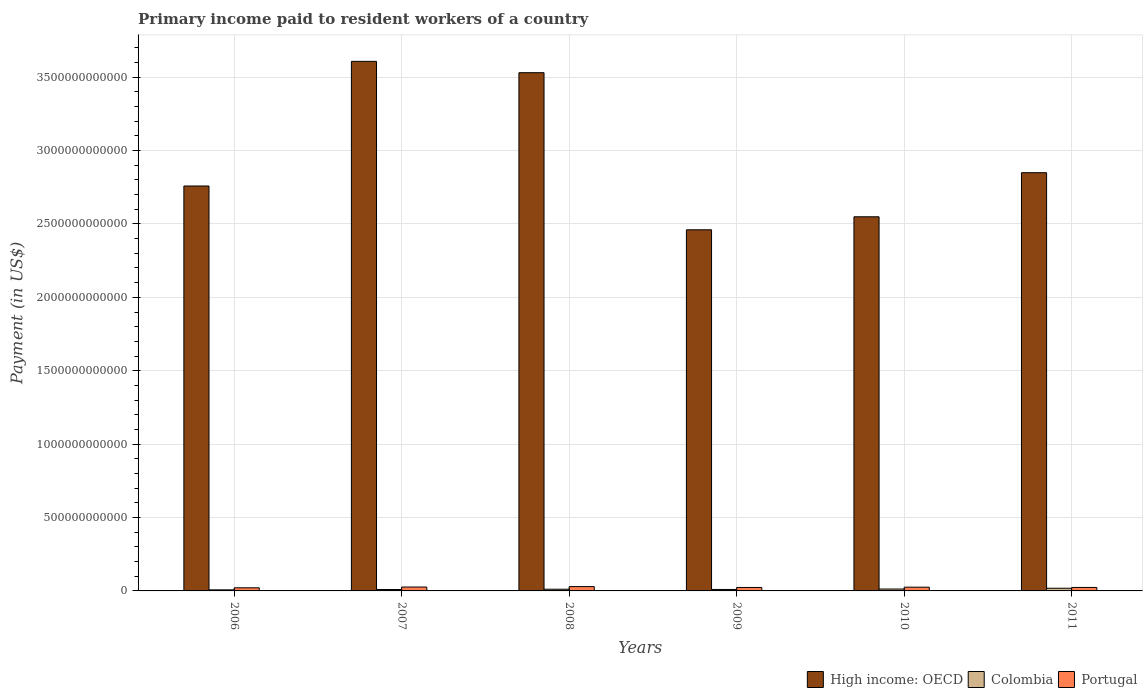How many bars are there on the 1st tick from the right?
Ensure brevity in your answer.  3. What is the amount paid to workers in Portugal in 2007?
Offer a terse response. 2.65e+1. Across all years, what is the maximum amount paid to workers in Portugal?
Your answer should be compact. 2.94e+1. Across all years, what is the minimum amount paid to workers in Colombia?
Your response must be concise. 7.27e+09. What is the total amount paid to workers in Portugal in the graph?
Your response must be concise. 1.50e+11. What is the difference between the amount paid to workers in Portugal in 2006 and that in 2009?
Your answer should be very brief. -2.39e+09. What is the difference between the amount paid to workers in Colombia in 2010 and the amount paid to workers in Portugal in 2009?
Your response must be concise. -1.07e+1. What is the average amount paid to workers in Colombia per year?
Provide a succinct answer. 1.16e+1. In the year 2007, what is the difference between the amount paid to workers in Colombia and amount paid to workers in Portugal?
Make the answer very short. -1.68e+1. What is the ratio of the amount paid to workers in Colombia in 2007 to that in 2011?
Offer a terse response. 0.53. Is the difference between the amount paid to workers in Colombia in 2007 and 2010 greater than the difference between the amount paid to workers in Portugal in 2007 and 2010?
Your response must be concise. No. What is the difference between the highest and the second highest amount paid to workers in Portugal?
Your answer should be compact. 2.91e+09. What is the difference between the highest and the lowest amount paid to workers in Colombia?
Give a very brief answer. 1.10e+1. In how many years, is the amount paid to workers in Colombia greater than the average amount paid to workers in Colombia taken over all years?
Offer a very short reply. 2. Is the sum of the amount paid to workers in Colombia in 2006 and 2009 greater than the maximum amount paid to workers in High income: OECD across all years?
Your response must be concise. No. What does the 2nd bar from the left in 2006 represents?
Keep it short and to the point. Colombia. What is the difference between two consecutive major ticks on the Y-axis?
Give a very brief answer. 5.00e+11. Does the graph contain grids?
Provide a succinct answer. Yes. How many legend labels are there?
Your answer should be compact. 3. What is the title of the graph?
Keep it short and to the point. Primary income paid to resident workers of a country. Does "Costa Rica" appear as one of the legend labels in the graph?
Your answer should be compact. No. What is the label or title of the Y-axis?
Provide a succinct answer. Payment (in US$). What is the Payment (in US$) of High income: OECD in 2006?
Your answer should be compact. 2.76e+12. What is the Payment (in US$) in Colombia in 2006?
Your answer should be compact. 7.27e+09. What is the Payment (in US$) in Portugal in 2006?
Keep it short and to the point. 2.12e+1. What is the Payment (in US$) in High income: OECD in 2007?
Your response must be concise. 3.61e+12. What is the Payment (in US$) of Colombia in 2007?
Give a very brief answer. 9.68e+09. What is the Payment (in US$) in Portugal in 2007?
Offer a very short reply. 2.65e+1. What is the Payment (in US$) of High income: OECD in 2008?
Offer a terse response. 3.53e+12. What is the Payment (in US$) of Colombia in 2008?
Offer a very short reply. 1.15e+1. What is the Payment (in US$) of Portugal in 2008?
Make the answer very short. 2.94e+1. What is the Payment (in US$) in High income: OECD in 2009?
Provide a succinct answer. 2.46e+12. What is the Payment (in US$) of Colombia in 2009?
Your response must be concise. 9.96e+09. What is the Payment (in US$) of Portugal in 2009?
Keep it short and to the point. 2.36e+1. What is the Payment (in US$) of High income: OECD in 2010?
Give a very brief answer. 2.55e+12. What is the Payment (in US$) in Colombia in 2010?
Your answer should be compact. 1.29e+1. What is the Payment (in US$) in Portugal in 2010?
Your answer should be very brief. 2.55e+1. What is the Payment (in US$) of High income: OECD in 2011?
Provide a short and direct response. 2.85e+12. What is the Payment (in US$) of Colombia in 2011?
Give a very brief answer. 1.83e+1. What is the Payment (in US$) in Portugal in 2011?
Your answer should be very brief. 2.36e+1. Across all years, what is the maximum Payment (in US$) of High income: OECD?
Offer a very short reply. 3.61e+12. Across all years, what is the maximum Payment (in US$) in Colombia?
Offer a very short reply. 1.83e+1. Across all years, what is the maximum Payment (in US$) of Portugal?
Offer a terse response. 2.94e+1. Across all years, what is the minimum Payment (in US$) in High income: OECD?
Your answer should be compact. 2.46e+12. Across all years, what is the minimum Payment (in US$) in Colombia?
Give a very brief answer. 7.27e+09. Across all years, what is the minimum Payment (in US$) of Portugal?
Make the answer very short. 2.12e+1. What is the total Payment (in US$) of High income: OECD in the graph?
Provide a succinct answer. 1.78e+13. What is the total Payment (in US$) of Colombia in the graph?
Keep it short and to the point. 6.96e+1. What is the total Payment (in US$) in Portugal in the graph?
Ensure brevity in your answer.  1.50e+11. What is the difference between the Payment (in US$) in High income: OECD in 2006 and that in 2007?
Ensure brevity in your answer.  -8.49e+11. What is the difference between the Payment (in US$) of Colombia in 2006 and that in 2007?
Your response must be concise. -2.42e+09. What is the difference between the Payment (in US$) of Portugal in 2006 and that in 2007?
Offer a terse response. -5.28e+09. What is the difference between the Payment (in US$) in High income: OECD in 2006 and that in 2008?
Give a very brief answer. -7.72e+11. What is the difference between the Payment (in US$) of Colombia in 2006 and that in 2008?
Give a very brief answer. -4.25e+09. What is the difference between the Payment (in US$) of Portugal in 2006 and that in 2008?
Ensure brevity in your answer.  -8.19e+09. What is the difference between the Payment (in US$) of High income: OECD in 2006 and that in 2009?
Make the answer very short. 2.98e+11. What is the difference between the Payment (in US$) of Colombia in 2006 and that in 2009?
Provide a short and direct response. -2.70e+09. What is the difference between the Payment (in US$) in Portugal in 2006 and that in 2009?
Provide a succinct answer. -2.39e+09. What is the difference between the Payment (in US$) of High income: OECD in 2006 and that in 2010?
Offer a very short reply. 2.10e+11. What is the difference between the Payment (in US$) in Colombia in 2006 and that in 2010?
Keep it short and to the point. -5.62e+09. What is the difference between the Payment (in US$) in Portugal in 2006 and that in 2010?
Keep it short and to the point. -4.24e+09. What is the difference between the Payment (in US$) of High income: OECD in 2006 and that in 2011?
Provide a succinct answer. -9.06e+1. What is the difference between the Payment (in US$) of Colombia in 2006 and that in 2011?
Provide a succinct answer. -1.10e+1. What is the difference between the Payment (in US$) in Portugal in 2006 and that in 2011?
Give a very brief answer. -2.42e+09. What is the difference between the Payment (in US$) in High income: OECD in 2007 and that in 2008?
Your answer should be compact. 7.73e+1. What is the difference between the Payment (in US$) in Colombia in 2007 and that in 2008?
Give a very brief answer. -1.83e+09. What is the difference between the Payment (in US$) in Portugal in 2007 and that in 2008?
Make the answer very short. -2.91e+09. What is the difference between the Payment (in US$) of High income: OECD in 2007 and that in 2009?
Give a very brief answer. 1.15e+12. What is the difference between the Payment (in US$) in Colombia in 2007 and that in 2009?
Offer a very short reply. -2.78e+08. What is the difference between the Payment (in US$) in Portugal in 2007 and that in 2009?
Provide a succinct answer. 2.89e+09. What is the difference between the Payment (in US$) of High income: OECD in 2007 and that in 2010?
Provide a short and direct response. 1.06e+12. What is the difference between the Payment (in US$) in Colombia in 2007 and that in 2010?
Offer a very short reply. -3.21e+09. What is the difference between the Payment (in US$) in Portugal in 2007 and that in 2010?
Make the answer very short. 1.03e+09. What is the difference between the Payment (in US$) in High income: OECD in 2007 and that in 2011?
Your answer should be very brief. 7.58e+11. What is the difference between the Payment (in US$) in Colombia in 2007 and that in 2011?
Keep it short and to the point. -8.58e+09. What is the difference between the Payment (in US$) in Portugal in 2007 and that in 2011?
Give a very brief answer. 2.85e+09. What is the difference between the Payment (in US$) of High income: OECD in 2008 and that in 2009?
Your response must be concise. 1.07e+12. What is the difference between the Payment (in US$) in Colombia in 2008 and that in 2009?
Keep it short and to the point. 1.55e+09. What is the difference between the Payment (in US$) of Portugal in 2008 and that in 2009?
Provide a succinct answer. 5.80e+09. What is the difference between the Payment (in US$) in High income: OECD in 2008 and that in 2010?
Give a very brief answer. 9.82e+11. What is the difference between the Payment (in US$) in Colombia in 2008 and that in 2010?
Offer a very short reply. -1.38e+09. What is the difference between the Payment (in US$) in Portugal in 2008 and that in 2010?
Ensure brevity in your answer.  3.95e+09. What is the difference between the Payment (in US$) of High income: OECD in 2008 and that in 2011?
Offer a very short reply. 6.81e+11. What is the difference between the Payment (in US$) in Colombia in 2008 and that in 2011?
Keep it short and to the point. -6.75e+09. What is the difference between the Payment (in US$) in Portugal in 2008 and that in 2011?
Give a very brief answer. 5.77e+09. What is the difference between the Payment (in US$) in High income: OECD in 2009 and that in 2010?
Ensure brevity in your answer.  -8.86e+1. What is the difference between the Payment (in US$) of Colombia in 2009 and that in 2010?
Your response must be concise. -2.93e+09. What is the difference between the Payment (in US$) in Portugal in 2009 and that in 2010?
Provide a succinct answer. -1.86e+09. What is the difference between the Payment (in US$) of High income: OECD in 2009 and that in 2011?
Offer a terse response. -3.89e+11. What is the difference between the Payment (in US$) in Colombia in 2009 and that in 2011?
Offer a very short reply. -8.30e+09. What is the difference between the Payment (in US$) in Portugal in 2009 and that in 2011?
Your response must be concise. -3.41e+07. What is the difference between the Payment (in US$) of High income: OECD in 2010 and that in 2011?
Provide a short and direct response. -3.00e+11. What is the difference between the Payment (in US$) of Colombia in 2010 and that in 2011?
Ensure brevity in your answer.  -5.37e+09. What is the difference between the Payment (in US$) of Portugal in 2010 and that in 2011?
Your answer should be very brief. 1.82e+09. What is the difference between the Payment (in US$) in High income: OECD in 2006 and the Payment (in US$) in Colombia in 2007?
Your answer should be compact. 2.75e+12. What is the difference between the Payment (in US$) in High income: OECD in 2006 and the Payment (in US$) in Portugal in 2007?
Make the answer very short. 2.73e+12. What is the difference between the Payment (in US$) in Colombia in 2006 and the Payment (in US$) in Portugal in 2007?
Give a very brief answer. -1.92e+1. What is the difference between the Payment (in US$) of High income: OECD in 2006 and the Payment (in US$) of Colombia in 2008?
Provide a succinct answer. 2.75e+12. What is the difference between the Payment (in US$) in High income: OECD in 2006 and the Payment (in US$) in Portugal in 2008?
Make the answer very short. 2.73e+12. What is the difference between the Payment (in US$) in Colombia in 2006 and the Payment (in US$) in Portugal in 2008?
Give a very brief answer. -2.21e+1. What is the difference between the Payment (in US$) in High income: OECD in 2006 and the Payment (in US$) in Colombia in 2009?
Keep it short and to the point. 2.75e+12. What is the difference between the Payment (in US$) in High income: OECD in 2006 and the Payment (in US$) in Portugal in 2009?
Offer a terse response. 2.73e+12. What is the difference between the Payment (in US$) of Colombia in 2006 and the Payment (in US$) of Portugal in 2009?
Your answer should be very brief. -1.63e+1. What is the difference between the Payment (in US$) in High income: OECD in 2006 and the Payment (in US$) in Colombia in 2010?
Provide a succinct answer. 2.75e+12. What is the difference between the Payment (in US$) in High income: OECD in 2006 and the Payment (in US$) in Portugal in 2010?
Make the answer very short. 2.73e+12. What is the difference between the Payment (in US$) in Colombia in 2006 and the Payment (in US$) in Portugal in 2010?
Your answer should be very brief. -1.82e+1. What is the difference between the Payment (in US$) in High income: OECD in 2006 and the Payment (in US$) in Colombia in 2011?
Make the answer very short. 2.74e+12. What is the difference between the Payment (in US$) of High income: OECD in 2006 and the Payment (in US$) of Portugal in 2011?
Provide a succinct answer. 2.73e+12. What is the difference between the Payment (in US$) of Colombia in 2006 and the Payment (in US$) of Portugal in 2011?
Give a very brief answer. -1.64e+1. What is the difference between the Payment (in US$) of High income: OECD in 2007 and the Payment (in US$) of Colombia in 2008?
Provide a short and direct response. 3.60e+12. What is the difference between the Payment (in US$) of High income: OECD in 2007 and the Payment (in US$) of Portugal in 2008?
Your response must be concise. 3.58e+12. What is the difference between the Payment (in US$) of Colombia in 2007 and the Payment (in US$) of Portugal in 2008?
Make the answer very short. -1.97e+1. What is the difference between the Payment (in US$) in High income: OECD in 2007 and the Payment (in US$) in Colombia in 2009?
Your response must be concise. 3.60e+12. What is the difference between the Payment (in US$) of High income: OECD in 2007 and the Payment (in US$) of Portugal in 2009?
Provide a succinct answer. 3.58e+12. What is the difference between the Payment (in US$) in Colombia in 2007 and the Payment (in US$) in Portugal in 2009?
Your answer should be very brief. -1.39e+1. What is the difference between the Payment (in US$) of High income: OECD in 2007 and the Payment (in US$) of Colombia in 2010?
Your response must be concise. 3.59e+12. What is the difference between the Payment (in US$) in High income: OECD in 2007 and the Payment (in US$) in Portugal in 2010?
Offer a very short reply. 3.58e+12. What is the difference between the Payment (in US$) in Colombia in 2007 and the Payment (in US$) in Portugal in 2010?
Your response must be concise. -1.58e+1. What is the difference between the Payment (in US$) in High income: OECD in 2007 and the Payment (in US$) in Colombia in 2011?
Make the answer very short. 3.59e+12. What is the difference between the Payment (in US$) in High income: OECD in 2007 and the Payment (in US$) in Portugal in 2011?
Offer a very short reply. 3.58e+12. What is the difference between the Payment (in US$) of Colombia in 2007 and the Payment (in US$) of Portugal in 2011?
Your answer should be very brief. -1.40e+1. What is the difference between the Payment (in US$) in High income: OECD in 2008 and the Payment (in US$) in Colombia in 2009?
Give a very brief answer. 3.52e+12. What is the difference between the Payment (in US$) in High income: OECD in 2008 and the Payment (in US$) in Portugal in 2009?
Ensure brevity in your answer.  3.51e+12. What is the difference between the Payment (in US$) in Colombia in 2008 and the Payment (in US$) in Portugal in 2009?
Make the answer very short. -1.21e+1. What is the difference between the Payment (in US$) of High income: OECD in 2008 and the Payment (in US$) of Colombia in 2010?
Your answer should be very brief. 3.52e+12. What is the difference between the Payment (in US$) in High income: OECD in 2008 and the Payment (in US$) in Portugal in 2010?
Make the answer very short. 3.50e+12. What is the difference between the Payment (in US$) in Colombia in 2008 and the Payment (in US$) in Portugal in 2010?
Give a very brief answer. -1.39e+1. What is the difference between the Payment (in US$) in High income: OECD in 2008 and the Payment (in US$) in Colombia in 2011?
Ensure brevity in your answer.  3.51e+12. What is the difference between the Payment (in US$) of High income: OECD in 2008 and the Payment (in US$) of Portugal in 2011?
Offer a very short reply. 3.51e+12. What is the difference between the Payment (in US$) in Colombia in 2008 and the Payment (in US$) in Portugal in 2011?
Your answer should be very brief. -1.21e+1. What is the difference between the Payment (in US$) in High income: OECD in 2009 and the Payment (in US$) in Colombia in 2010?
Keep it short and to the point. 2.45e+12. What is the difference between the Payment (in US$) of High income: OECD in 2009 and the Payment (in US$) of Portugal in 2010?
Your answer should be compact. 2.43e+12. What is the difference between the Payment (in US$) of Colombia in 2009 and the Payment (in US$) of Portugal in 2010?
Give a very brief answer. -1.55e+1. What is the difference between the Payment (in US$) of High income: OECD in 2009 and the Payment (in US$) of Colombia in 2011?
Offer a terse response. 2.44e+12. What is the difference between the Payment (in US$) in High income: OECD in 2009 and the Payment (in US$) in Portugal in 2011?
Make the answer very short. 2.44e+12. What is the difference between the Payment (in US$) in Colombia in 2009 and the Payment (in US$) in Portugal in 2011?
Provide a succinct answer. -1.37e+1. What is the difference between the Payment (in US$) of High income: OECD in 2010 and the Payment (in US$) of Colombia in 2011?
Ensure brevity in your answer.  2.53e+12. What is the difference between the Payment (in US$) of High income: OECD in 2010 and the Payment (in US$) of Portugal in 2011?
Offer a terse response. 2.52e+12. What is the difference between the Payment (in US$) of Colombia in 2010 and the Payment (in US$) of Portugal in 2011?
Your answer should be very brief. -1.07e+1. What is the average Payment (in US$) of High income: OECD per year?
Ensure brevity in your answer.  2.96e+12. What is the average Payment (in US$) in Colombia per year?
Give a very brief answer. 1.16e+1. What is the average Payment (in US$) of Portugal per year?
Ensure brevity in your answer.  2.50e+1. In the year 2006, what is the difference between the Payment (in US$) in High income: OECD and Payment (in US$) in Colombia?
Make the answer very short. 2.75e+12. In the year 2006, what is the difference between the Payment (in US$) of High income: OECD and Payment (in US$) of Portugal?
Your answer should be compact. 2.74e+12. In the year 2006, what is the difference between the Payment (in US$) in Colombia and Payment (in US$) in Portugal?
Your response must be concise. -1.39e+1. In the year 2007, what is the difference between the Payment (in US$) in High income: OECD and Payment (in US$) in Colombia?
Ensure brevity in your answer.  3.60e+12. In the year 2007, what is the difference between the Payment (in US$) in High income: OECD and Payment (in US$) in Portugal?
Offer a terse response. 3.58e+12. In the year 2007, what is the difference between the Payment (in US$) of Colombia and Payment (in US$) of Portugal?
Offer a terse response. -1.68e+1. In the year 2008, what is the difference between the Payment (in US$) of High income: OECD and Payment (in US$) of Colombia?
Provide a succinct answer. 3.52e+12. In the year 2008, what is the difference between the Payment (in US$) of High income: OECD and Payment (in US$) of Portugal?
Ensure brevity in your answer.  3.50e+12. In the year 2008, what is the difference between the Payment (in US$) in Colombia and Payment (in US$) in Portugal?
Keep it short and to the point. -1.79e+1. In the year 2009, what is the difference between the Payment (in US$) of High income: OECD and Payment (in US$) of Colombia?
Offer a terse response. 2.45e+12. In the year 2009, what is the difference between the Payment (in US$) in High income: OECD and Payment (in US$) in Portugal?
Offer a terse response. 2.44e+12. In the year 2009, what is the difference between the Payment (in US$) of Colombia and Payment (in US$) of Portugal?
Your answer should be compact. -1.36e+1. In the year 2010, what is the difference between the Payment (in US$) of High income: OECD and Payment (in US$) of Colombia?
Ensure brevity in your answer.  2.54e+12. In the year 2010, what is the difference between the Payment (in US$) of High income: OECD and Payment (in US$) of Portugal?
Make the answer very short. 2.52e+12. In the year 2010, what is the difference between the Payment (in US$) in Colombia and Payment (in US$) in Portugal?
Give a very brief answer. -1.26e+1. In the year 2011, what is the difference between the Payment (in US$) in High income: OECD and Payment (in US$) in Colombia?
Give a very brief answer. 2.83e+12. In the year 2011, what is the difference between the Payment (in US$) in High income: OECD and Payment (in US$) in Portugal?
Give a very brief answer. 2.83e+12. In the year 2011, what is the difference between the Payment (in US$) in Colombia and Payment (in US$) in Portugal?
Your answer should be very brief. -5.38e+09. What is the ratio of the Payment (in US$) in High income: OECD in 2006 to that in 2007?
Your answer should be very brief. 0.76. What is the ratio of the Payment (in US$) of Colombia in 2006 to that in 2007?
Your answer should be compact. 0.75. What is the ratio of the Payment (in US$) of Portugal in 2006 to that in 2007?
Offer a very short reply. 0.8. What is the ratio of the Payment (in US$) in High income: OECD in 2006 to that in 2008?
Your answer should be compact. 0.78. What is the ratio of the Payment (in US$) of Colombia in 2006 to that in 2008?
Provide a short and direct response. 0.63. What is the ratio of the Payment (in US$) of Portugal in 2006 to that in 2008?
Give a very brief answer. 0.72. What is the ratio of the Payment (in US$) of High income: OECD in 2006 to that in 2009?
Provide a succinct answer. 1.12. What is the ratio of the Payment (in US$) of Colombia in 2006 to that in 2009?
Your response must be concise. 0.73. What is the ratio of the Payment (in US$) of Portugal in 2006 to that in 2009?
Offer a very short reply. 0.9. What is the ratio of the Payment (in US$) of High income: OECD in 2006 to that in 2010?
Your response must be concise. 1.08. What is the ratio of the Payment (in US$) in Colombia in 2006 to that in 2010?
Keep it short and to the point. 0.56. What is the ratio of the Payment (in US$) in Portugal in 2006 to that in 2010?
Keep it short and to the point. 0.83. What is the ratio of the Payment (in US$) of High income: OECD in 2006 to that in 2011?
Make the answer very short. 0.97. What is the ratio of the Payment (in US$) of Colombia in 2006 to that in 2011?
Provide a succinct answer. 0.4. What is the ratio of the Payment (in US$) of Portugal in 2006 to that in 2011?
Provide a short and direct response. 0.9. What is the ratio of the Payment (in US$) in High income: OECD in 2007 to that in 2008?
Your response must be concise. 1.02. What is the ratio of the Payment (in US$) of Colombia in 2007 to that in 2008?
Your response must be concise. 0.84. What is the ratio of the Payment (in US$) of Portugal in 2007 to that in 2008?
Keep it short and to the point. 0.9. What is the ratio of the Payment (in US$) in High income: OECD in 2007 to that in 2009?
Offer a terse response. 1.47. What is the ratio of the Payment (in US$) in Colombia in 2007 to that in 2009?
Your answer should be compact. 0.97. What is the ratio of the Payment (in US$) in Portugal in 2007 to that in 2009?
Give a very brief answer. 1.12. What is the ratio of the Payment (in US$) in High income: OECD in 2007 to that in 2010?
Keep it short and to the point. 1.42. What is the ratio of the Payment (in US$) in Colombia in 2007 to that in 2010?
Your answer should be compact. 0.75. What is the ratio of the Payment (in US$) in Portugal in 2007 to that in 2010?
Your answer should be very brief. 1.04. What is the ratio of the Payment (in US$) of High income: OECD in 2007 to that in 2011?
Give a very brief answer. 1.27. What is the ratio of the Payment (in US$) in Colombia in 2007 to that in 2011?
Offer a very short reply. 0.53. What is the ratio of the Payment (in US$) in Portugal in 2007 to that in 2011?
Your response must be concise. 1.12. What is the ratio of the Payment (in US$) of High income: OECD in 2008 to that in 2009?
Provide a short and direct response. 1.44. What is the ratio of the Payment (in US$) of Colombia in 2008 to that in 2009?
Provide a succinct answer. 1.16. What is the ratio of the Payment (in US$) of Portugal in 2008 to that in 2009?
Offer a terse response. 1.25. What is the ratio of the Payment (in US$) of High income: OECD in 2008 to that in 2010?
Your answer should be compact. 1.39. What is the ratio of the Payment (in US$) of Colombia in 2008 to that in 2010?
Your answer should be compact. 0.89. What is the ratio of the Payment (in US$) in Portugal in 2008 to that in 2010?
Offer a very short reply. 1.16. What is the ratio of the Payment (in US$) of High income: OECD in 2008 to that in 2011?
Keep it short and to the point. 1.24. What is the ratio of the Payment (in US$) of Colombia in 2008 to that in 2011?
Provide a short and direct response. 0.63. What is the ratio of the Payment (in US$) in Portugal in 2008 to that in 2011?
Offer a very short reply. 1.24. What is the ratio of the Payment (in US$) of High income: OECD in 2009 to that in 2010?
Make the answer very short. 0.97. What is the ratio of the Payment (in US$) of Colombia in 2009 to that in 2010?
Ensure brevity in your answer.  0.77. What is the ratio of the Payment (in US$) in Portugal in 2009 to that in 2010?
Give a very brief answer. 0.93. What is the ratio of the Payment (in US$) of High income: OECD in 2009 to that in 2011?
Your answer should be compact. 0.86. What is the ratio of the Payment (in US$) of Colombia in 2009 to that in 2011?
Ensure brevity in your answer.  0.55. What is the ratio of the Payment (in US$) of High income: OECD in 2010 to that in 2011?
Offer a very short reply. 0.89. What is the ratio of the Payment (in US$) in Colombia in 2010 to that in 2011?
Provide a succinct answer. 0.71. What is the ratio of the Payment (in US$) of Portugal in 2010 to that in 2011?
Give a very brief answer. 1.08. What is the difference between the highest and the second highest Payment (in US$) in High income: OECD?
Keep it short and to the point. 7.73e+1. What is the difference between the highest and the second highest Payment (in US$) in Colombia?
Provide a short and direct response. 5.37e+09. What is the difference between the highest and the second highest Payment (in US$) in Portugal?
Offer a very short reply. 2.91e+09. What is the difference between the highest and the lowest Payment (in US$) in High income: OECD?
Offer a terse response. 1.15e+12. What is the difference between the highest and the lowest Payment (in US$) of Colombia?
Your response must be concise. 1.10e+1. What is the difference between the highest and the lowest Payment (in US$) of Portugal?
Your answer should be compact. 8.19e+09. 